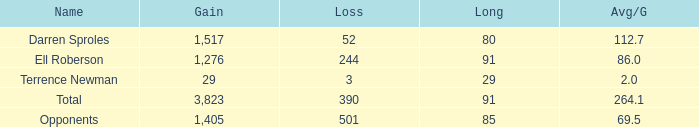What's the sum of all average yards gained when the gained yards is under 1,276 and lost more than 3 yards? None. 